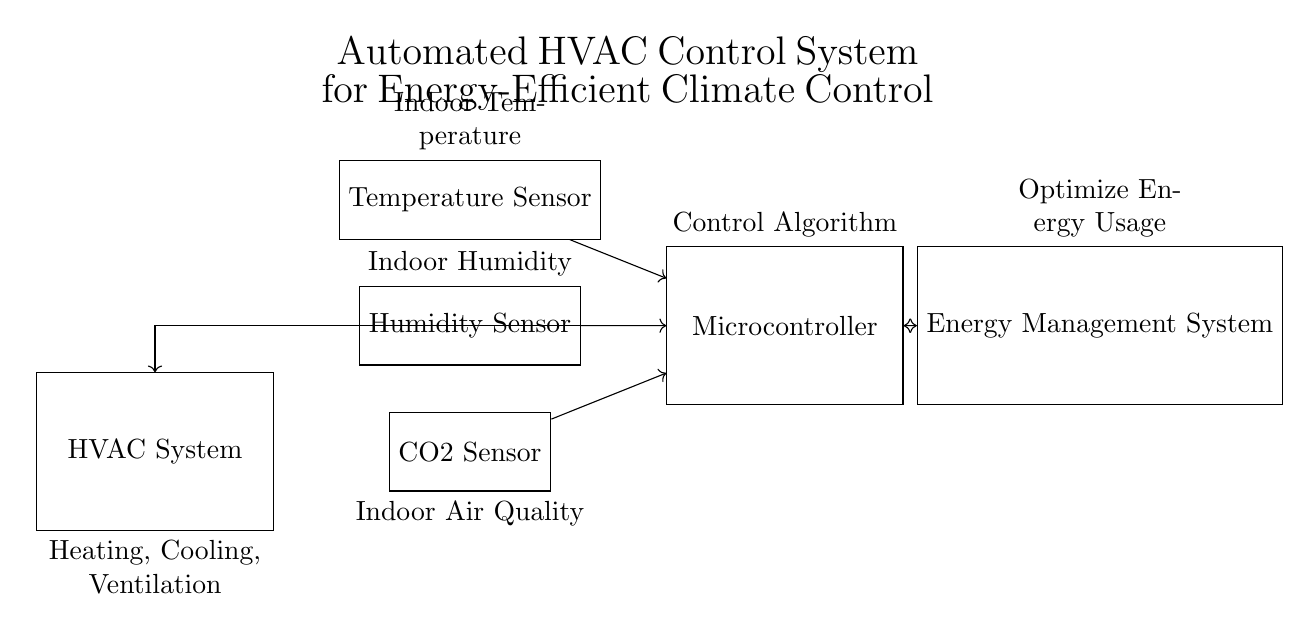What are the components in the circuit? The components include HVAC System, Temperature Sensor, Humidity Sensor, CO2 Sensor, Microcontroller, and Energy Management System.
Answer: HVAC System, Temperature Sensor, Humidity Sensor, CO2 Sensor, Microcontroller, Energy Management System What does the microcontroller connect to? The microcontroller has connections to the Temperature Sensor, Humidity Sensor, CO2 Sensor, HVAC System, and Energy Management System.
Answer: Temperature Sensor, Humidity Sensor, CO2 Sensor, HVAC System, Energy Management System What is the role of the Energy Management System? The Energy Management System is responsible for optimizing energy usage based on the data received from the microcontroller.
Answer: Optimize energy usage What sensors are used for indoor air quality monitoring? The sensors used for indoor air quality monitoring include the CO2 Sensor and indirectly the Temperature and Humidity Sensors, as they affect air quality.
Answer: CO2 Sensor How does the information flow from sensors to HVAC System? Information flows first from the Temperature, Humidity, and CO2 Sensors to the Microcontroller, which then controls the HVAC System based on the received data.
Answer: Through Microcontroller What is the purpose of the control algorithm in the microcontroller? The control algorithm processes sensor data to make decisions that maintain optimal temperature and air quality while minimizing energy consumption.
Answer: Maintain optimal conditions What is the overall function of the HVAC control system? The overall function is to maintain optimal temperature and air quality while minimizing energy consumption through automated control processes.
Answer: Automated climate control 